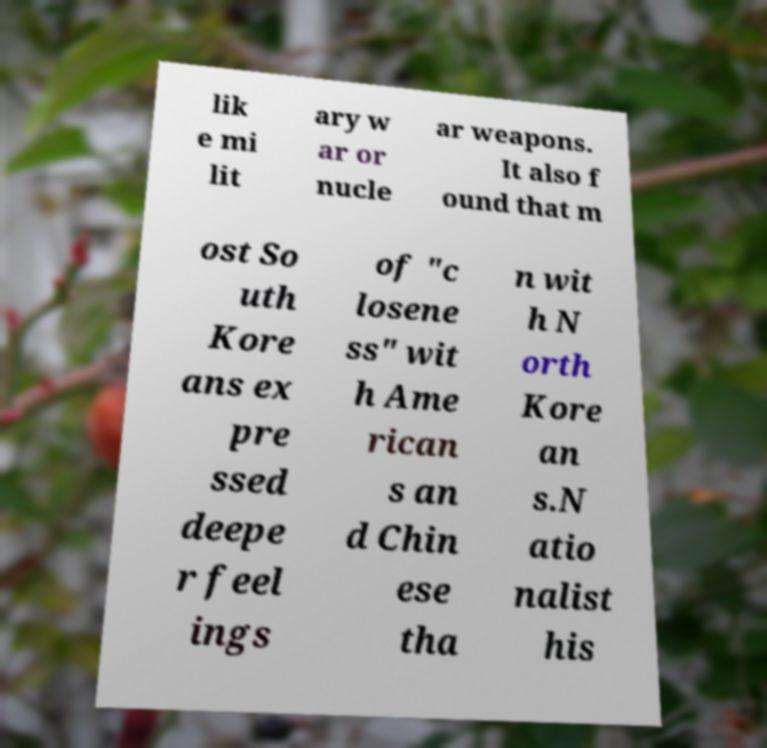Could you assist in decoding the text presented in this image and type it out clearly? lik e mi lit ary w ar or nucle ar weapons. It also f ound that m ost So uth Kore ans ex pre ssed deepe r feel ings of "c losene ss" wit h Ame rican s an d Chin ese tha n wit h N orth Kore an s.N atio nalist his 